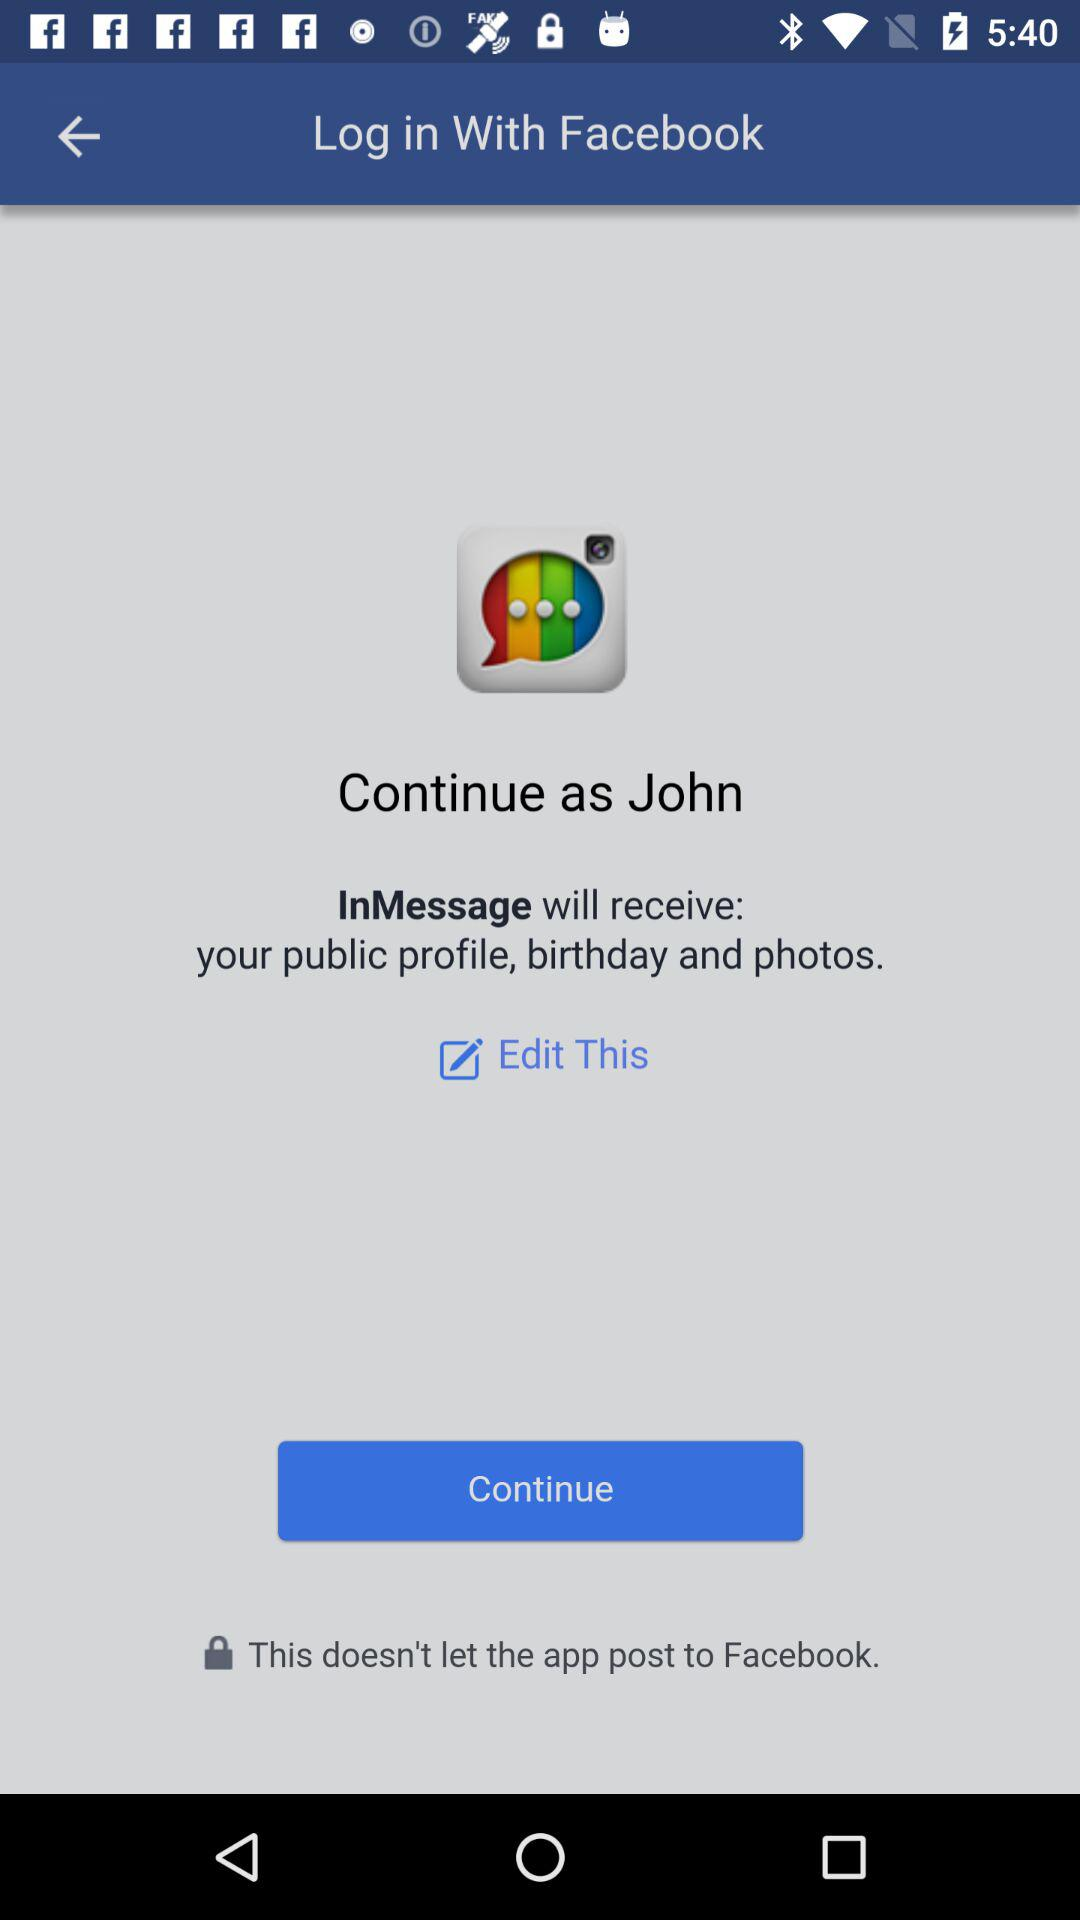What application can be used to continue? The application that can be used to continue is "Facebook". 